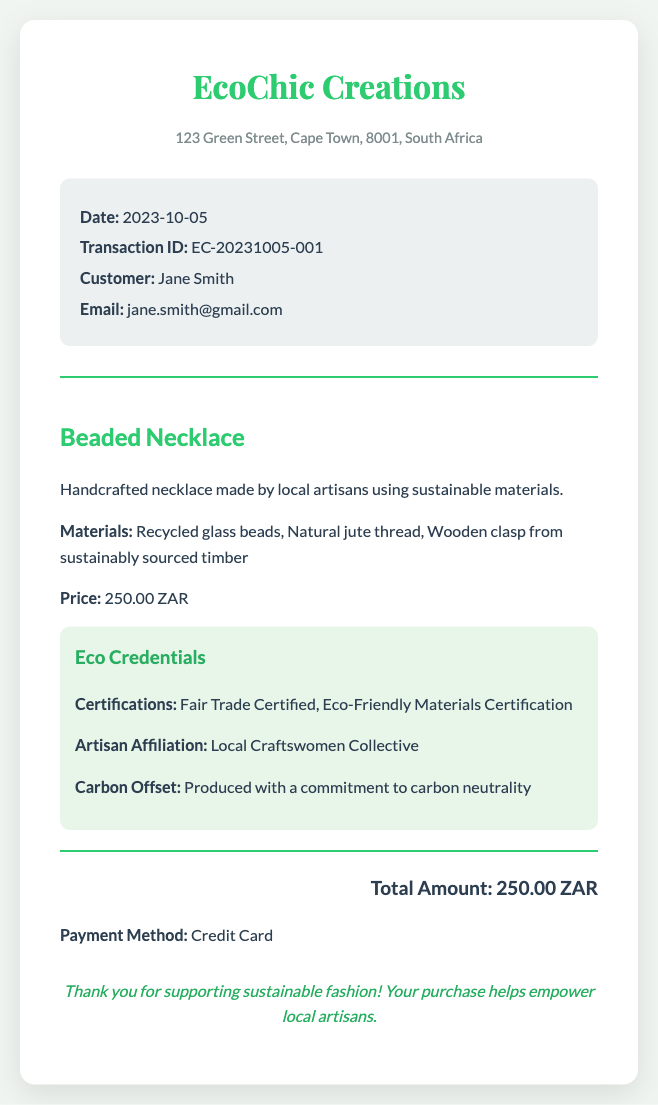What is the store's name? The store's name is presented prominently at the top of the receipt.
Answer: EcoChic Creations What is the date of the transaction? The date is clearly stated in the transaction details section of the receipt.
Answer: 2023-10-05 What materials are used in the Beaded Necklace? The materials are listed under the item details for the necklace.
Answer: Recycled glass beads, Natural jute thread, Wooden clasp from sustainably sourced timber What is the price of the Beaded Necklace? The price is specified in the item details section.
Answer: 250.00 ZAR What certifications does the item have? Certifications are listed under the eco credentials section of the receipt.
Answer: Fair Trade Certified, Eco-Friendly Materials Certification What is the total amount of the transaction? The total is summarized at the bottom of the receipt after item details.
Answer: 250.00 ZAR What payment method was used? The payment method is mentioned just before the thank you note.
Answer: Credit Card Who is the customer? The customer's name is mentioned in the transaction details section.
Answer: Jane Smith What artisan group is the product affiliated with? The artisan affiliation is found under eco credentials in the item details.
Answer: Local Craftswomen Collective 